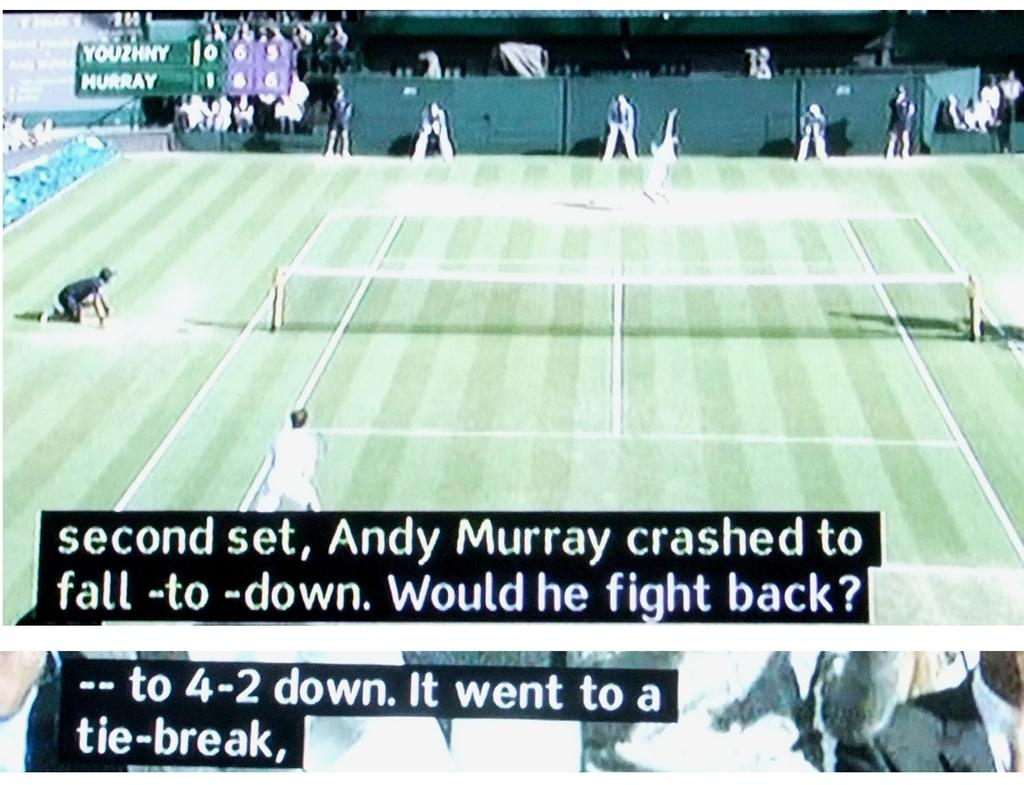<image>
Present a compact description of the photo's key features. An image of a tennis court with Second Set, Andy Murray on the monitor. 